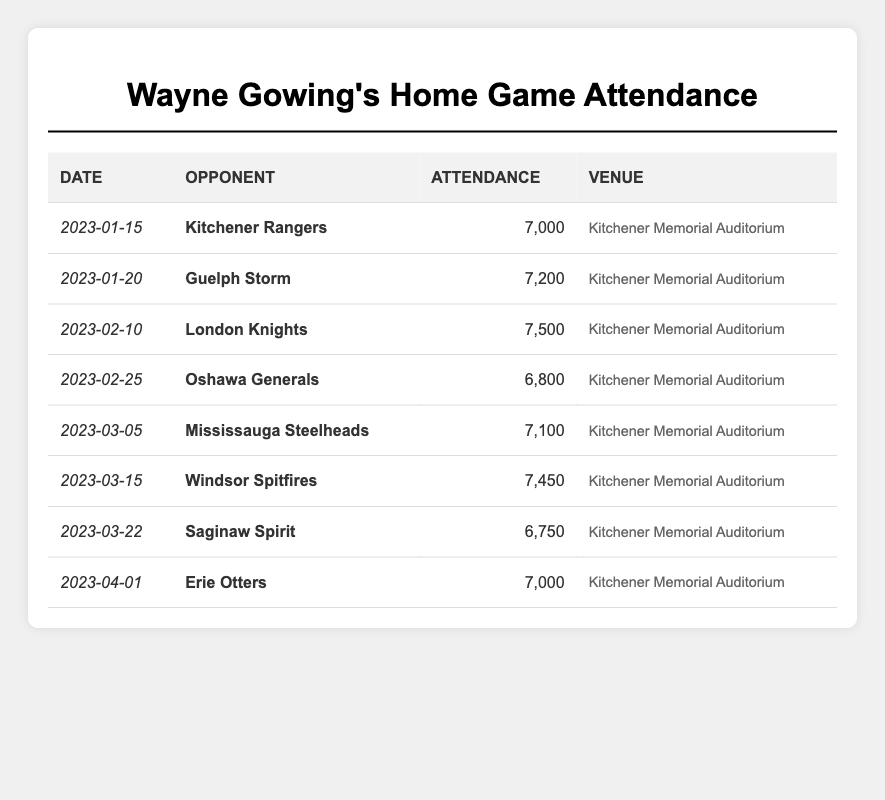What was the highest attendance recorded for Wayne Gowing's home games? The table shows the attendance for each game. The highest attendance is 7,500 for the game against the London Knights on February 10, 2023.
Answer: 7,500 Which team did Wayne Gowing play against on January 20, 2023? According to the table, Wayne Gowing's team played against the Guelph Storm on January 20, 2023.
Answer: Guelph Storm What is the total attendance for all of Wayne Gowing's home games? To find the total attendance, we add all the numbers: 7000 + 7200 + 7500 + 6800 + 7100 + 7450 + 6750 + 7000 = 52,000.
Answer: 52,000 Did the attendance exceed 7,000 in all home games? By checking the attendance figures in the table, we see that on February 25 and March 22, the attendance was below 7,000. Therefore, the statement is false.
Answer: No What was the average attendance for Wayne Gowing's home games? To calculate the average, add all the attendance figures (52,000) and then divide by the number of games (8): 52,000 / 8 = 6,500.
Answer: 6,500 Which game had the lowest attendance and what was it? The table reveals that the lowest attendance was 6,750 for the game against the Saginaw Spirit on March 22, 2023.
Answer: 6,750 How many games had an attendance of 7,000 or more? By counting the entries in the table, five games had attendance figures of 7,000 or more: January 20, February 10, March 5, March 15, and April 1.
Answer: 5 What is the difference between the highest and lowest attendance figures? The highest attendance is 7,500 and the lowest is 6,750, so the difference is 7,500 - 6,750 = 750.
Answer: 750 Which opponent had the highest recorded attendance? The opponent with the highest recorded attendance is the London Knights, with 7,500 attendees on February 10, 2023.
Answer: London Knights Was the attendance greater than 7,200 against the Kitchener Rangers? The attendance for the game against Kitchener Rangers on January 15, 2023, was 7,000, which is not greater than 7,200.
Answer: No 